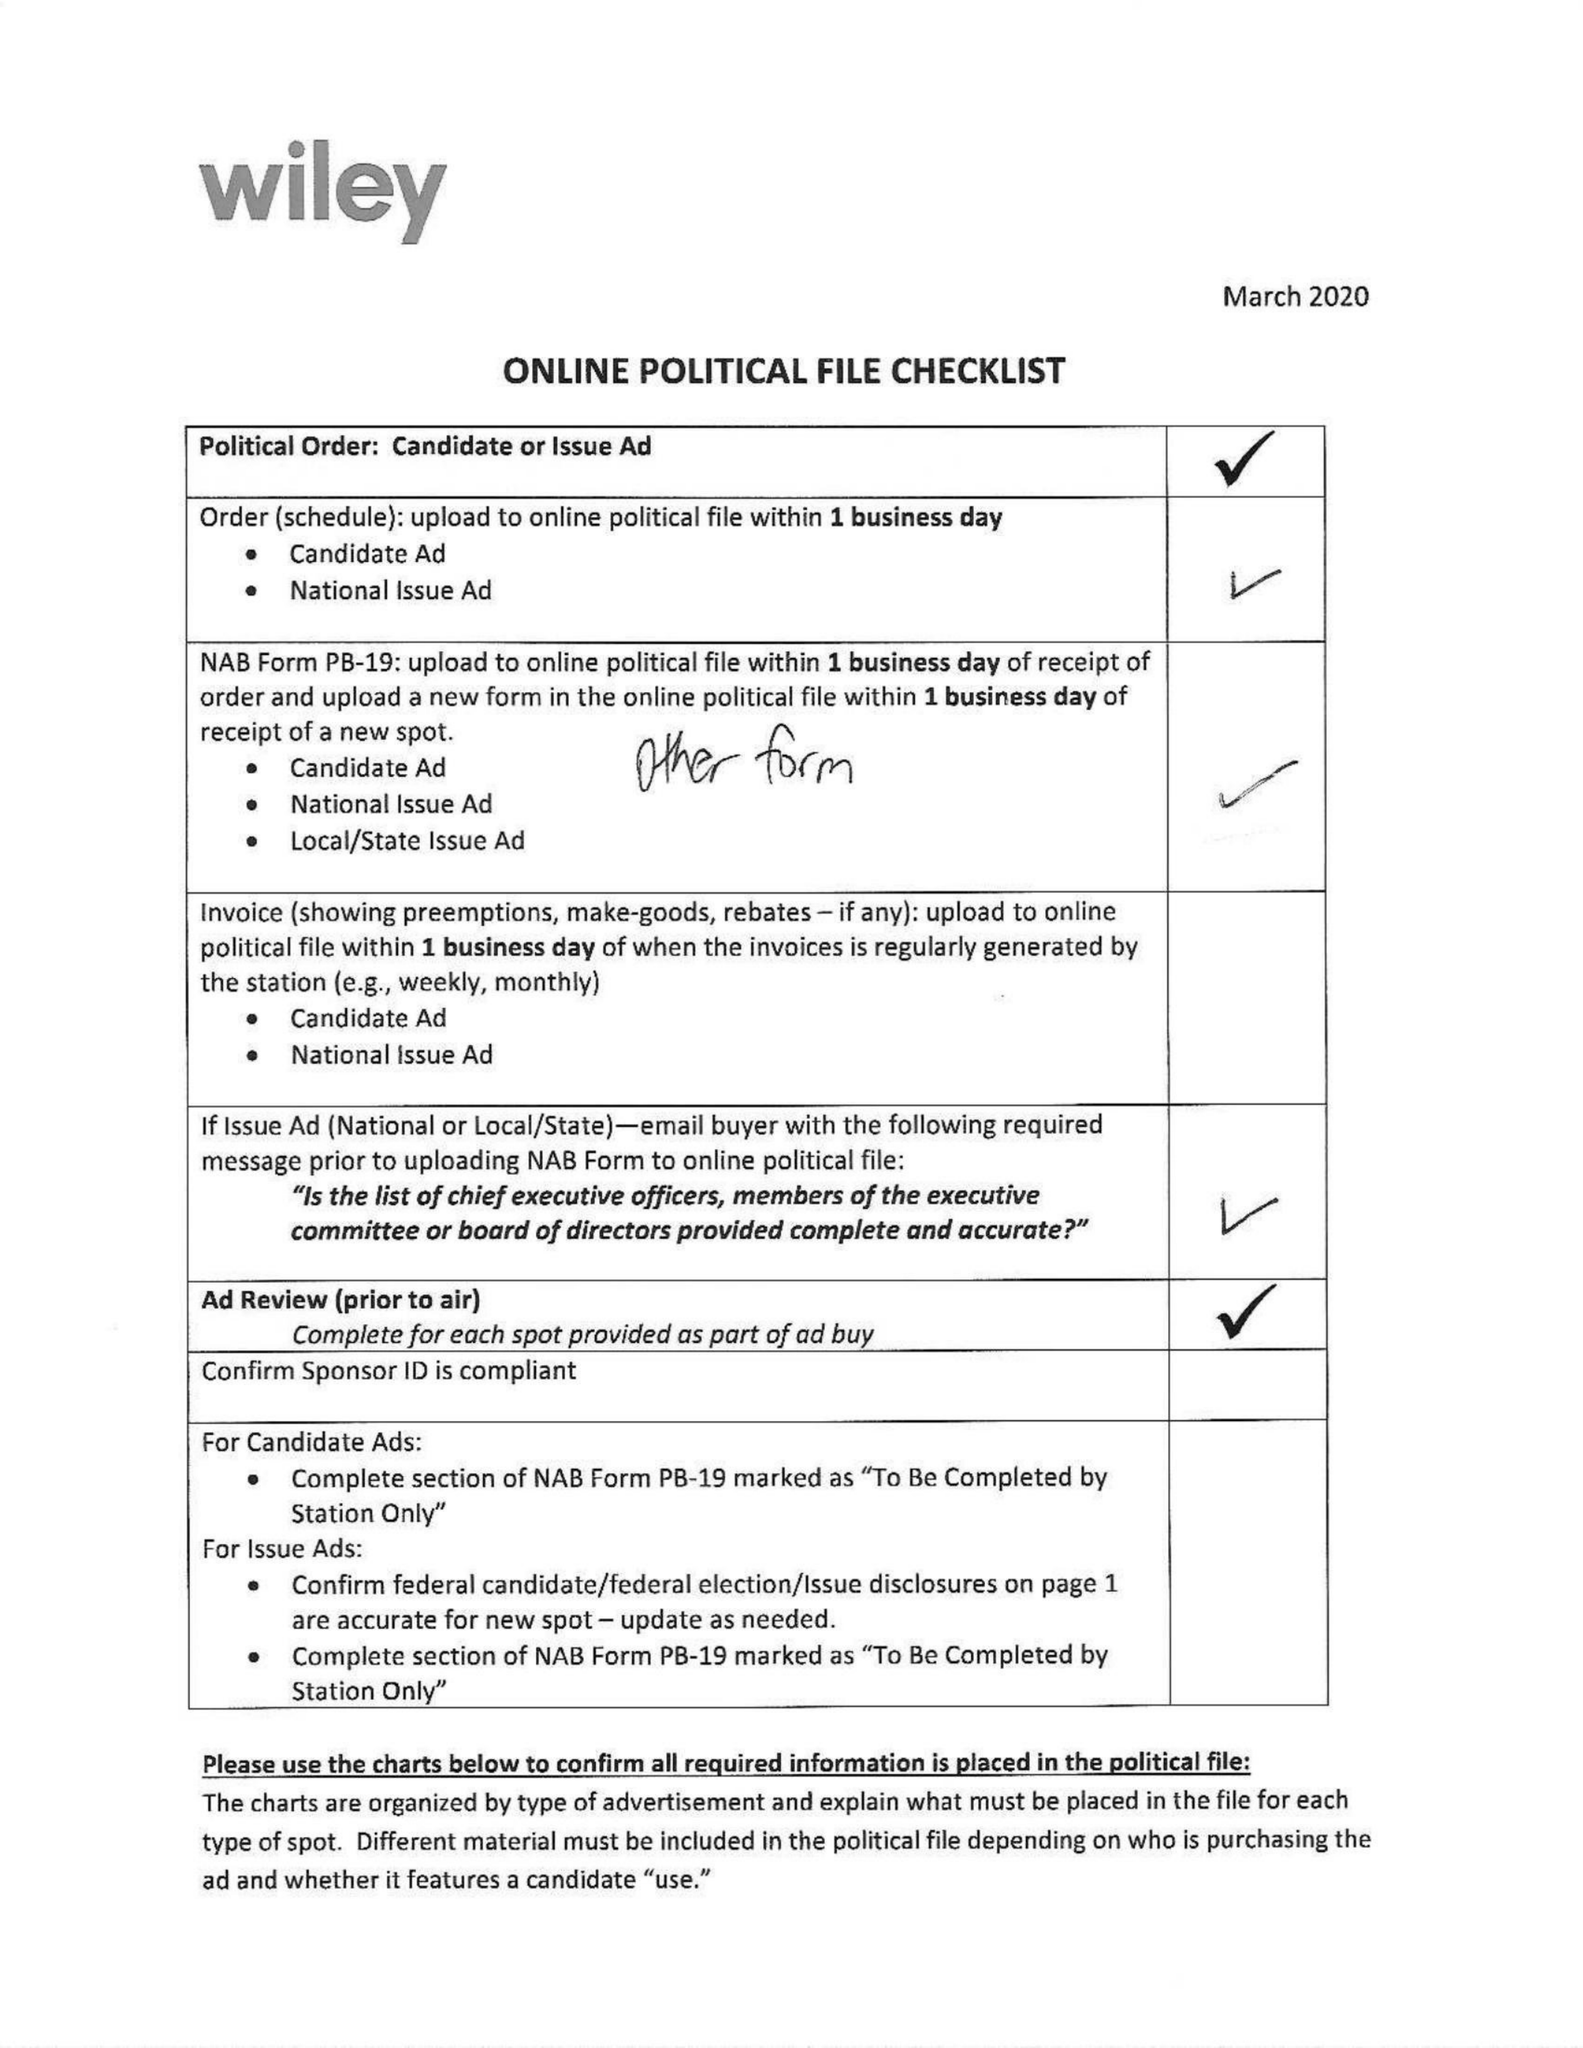What is the value for the advertiser?
Answer the question using a single word or phrase. CLUB FOR GROWTH ACTION 